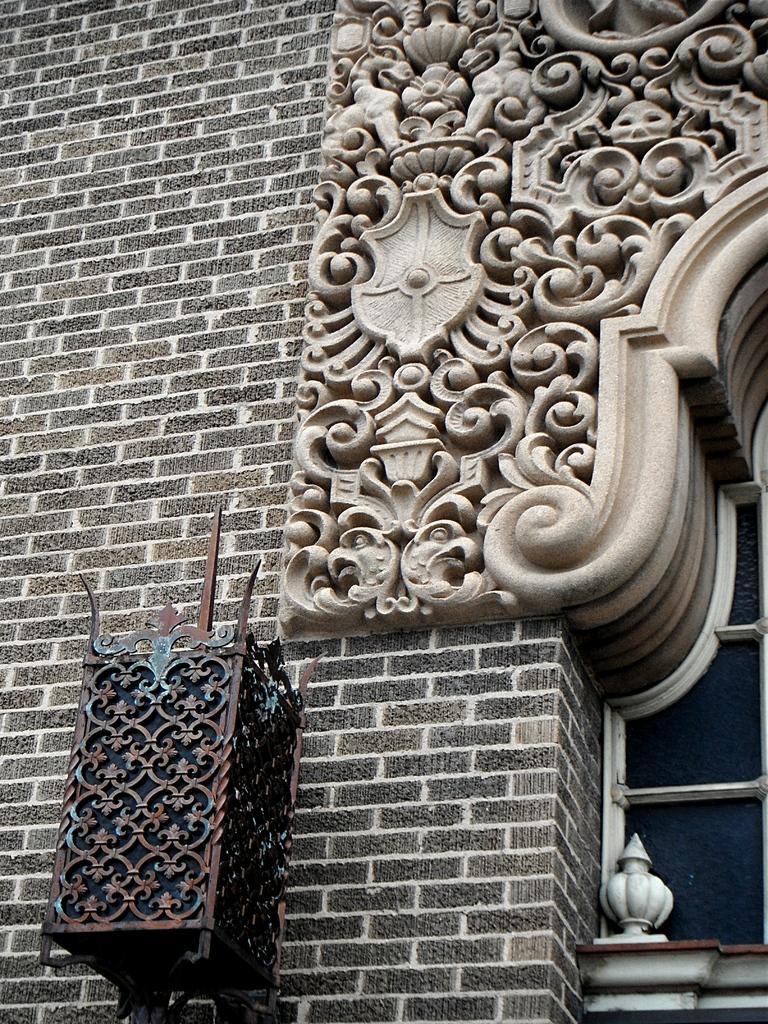How would you summarize this image in a sentence or two? In this picture there is a beautifully crafted design arch on the brick wall. In the front we can see the metal design light box hanging on the wall. 